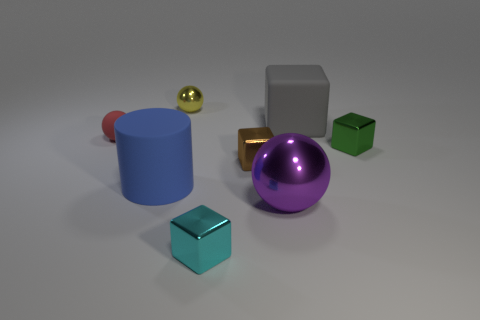The small object that is both in front of the rubber cube and left of the tiny cyan metal cube has what shape?
Offer a very short reply. Sphere. What is the color of the cube that is the same size as the cylinder?
Ensure brevity in your answer.  Gray. There is a red rubber sphere that is behind the tiny cyan metal cube; is its size the same as the brown block to the right of the tiny matte ball?
Your answer should be very brief. Yes. What is the object that is both behind the tiny red rubber thing and on the right side of the big purple metallic thing made of?
Give a very brief answer. Rubber. How many other objects are the same size as the green metallic object?
Offer a terse response. 4. What material is the small block in front of the large cylinder?
Ensure brevity in your answer.  Metal. Is the blue matte thing the same shape as the tiny cyan object?
Your response must be concise. No. How many other objects are there of the same shape as the green thing?
Offer a very short reply. 3. What color is the small sphere behind the small red sphere?
Offer a terse response. Yellow. Do the brown metallic object and the matte sphere have the same size?
Offer a terse response. Yes. 